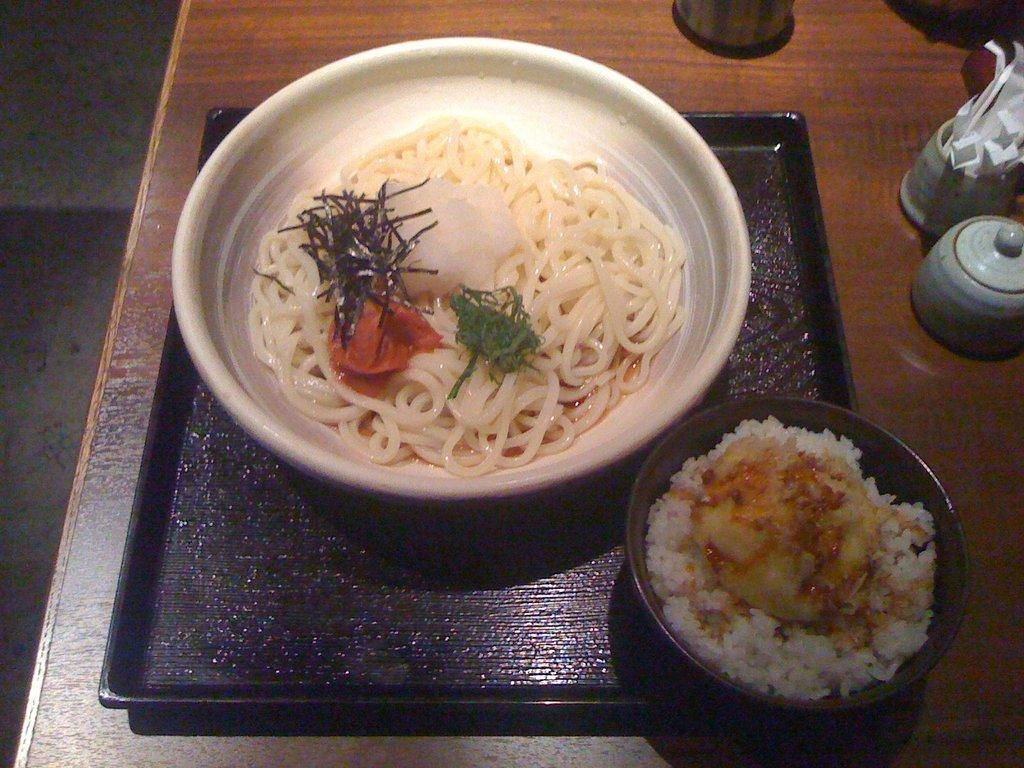What is in the bowls that are visible in the image? There are bowls with food in the image. How are the bowls arranged or supported in the image? The bowls are on a tray in the image. What is the tray and some objects resting on in the image? The tray and some objects are on a wooden platform in the image. What can be seen in the background of the image? The floor is visible in the background of the image. What type of mine is depicted in the image? There is no mine present in the image; it features bowls with food on a tray and a wooden platform. Can you see any cracks in the wooden platform in the image? The image does not provide enough detail to determine if there are any cracks in the wooden platform. Is there a carriage visible in the image? There is no carriage present in the image. 